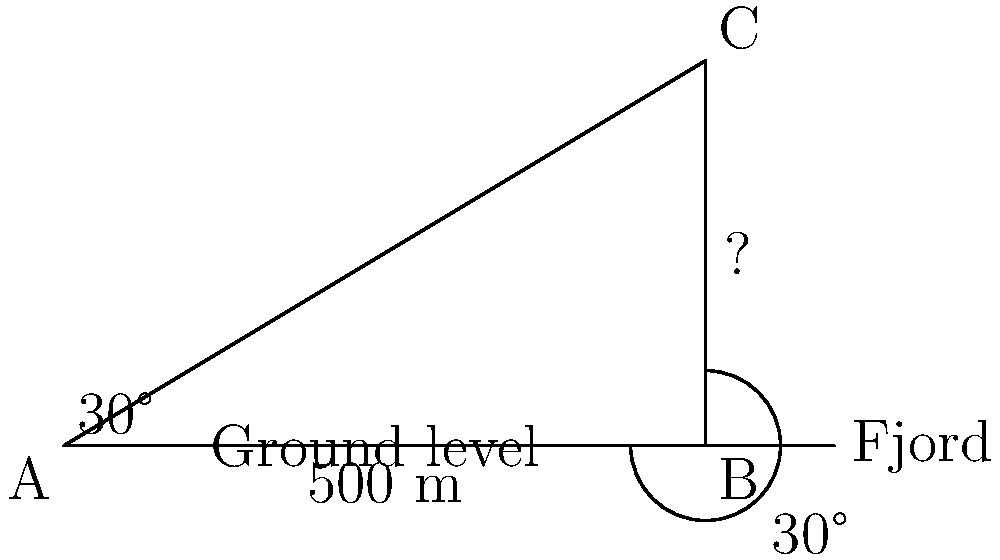During your time in Furnes, Norway in the early 60s, you decided to measure the height of a nearby fjord. Standing at point A, you observe the top of the fjord at point C. The distance from your position to the base of the fjord (point B) is 500 meters, and the angle of elevation to the top of the fjord is 30°. Calculate the height of the fjord. Let's solve this step-by-step using trigonometric ratios:

1) We have a right-angled triangle ABC, where:
   - AB is the ground distance (500 m)
   - BC is the height of the fjord (what we're looking for)
   - Angle BAC is 30°

2) In a right-angled triangle, tangent of an angle is the ratio of the opposite side to the adjacent side.

3) For angle BAC (30°):

   $$\tan(30°) = \frac{\text{opposite}}{\text{adjacent}} = \frac{BC}{AB}$$

4) We know that $\tan(30°) = \frac{1}{\sqrt{3}} \approx 0.577$

5) Substituting the known values:

   $$0.577 = \frac{BC}{500}$$

6) Cross multiply:

   $$BC = 500 \times 0.577 = 288.5$$

7) Therefore, the height of the fjord (BC) is approximately 288.5 meters.
Answer: 288.5 meters 